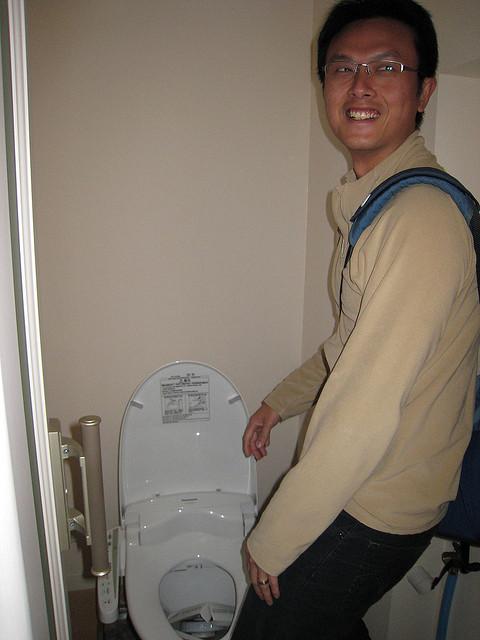Is the lid closed?
Concise answer only. No. Is the guy using earbuds?
Answer briefly. No. Which room is this?
Keep it brief. Bathroom. What type of pants is he wearing?
Give a very brief answer. Jeans. What color are the pants?
Answer briefly. Black. Where is the man leaning?
Be succinct. Bathroom. How many rolls of toilet tissue do you see?
Keep it brief. 0. Who is in the photo?
Give a very brief answer. Man. What color is the man's shirt?
Write a very short answer. Tan. What is this man doing?
Short answer required. Peeing. Is there evidence of an alcoholic beverage?
Be succinct. No. Where is the carry-on?
Short answer required. Backpack. Is the man planning to use the toilet?
Keep it brief. Yes. 